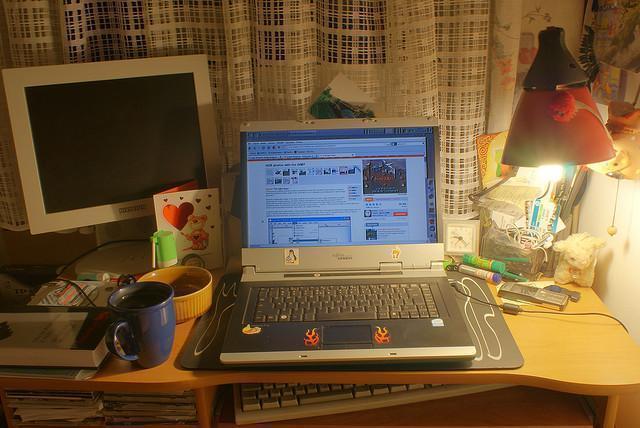How many keys are on a keyboard?
Pick the correct solution from the four options below to address the question.
Options: 101, 112, 100, 110. 101. 